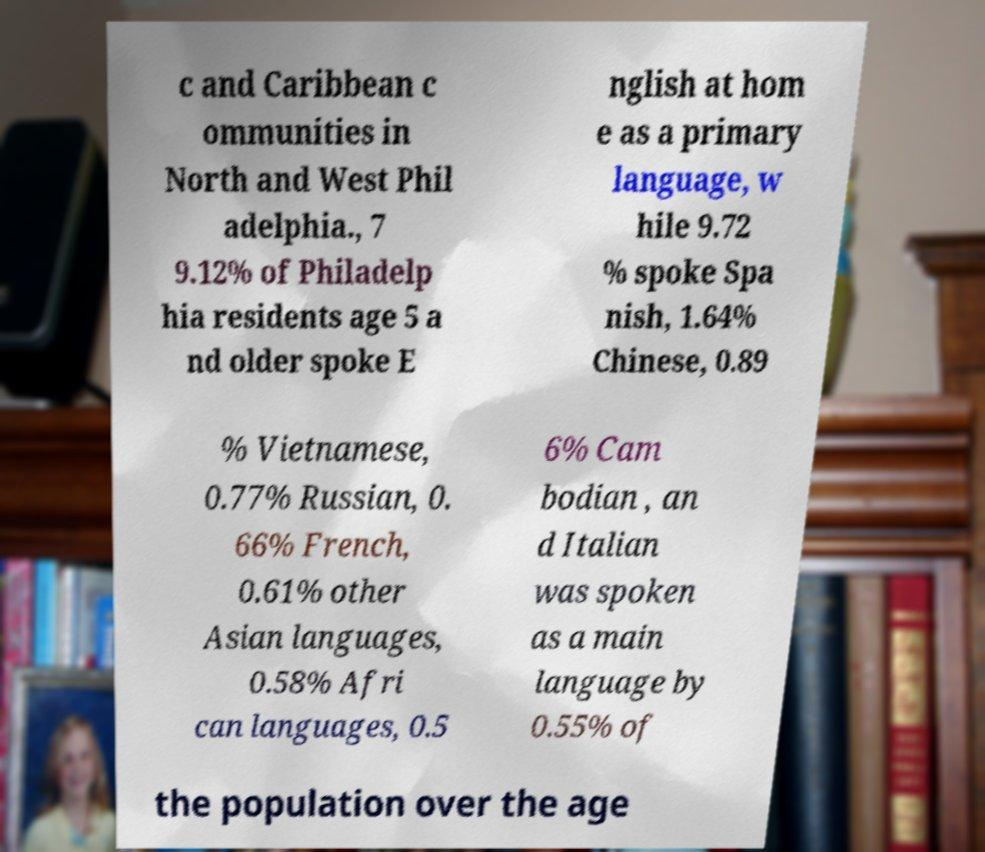I need the written content from this picture converted into text. Can you do that? c and Caribbean c ommunities in North and West Phil adelphia., 7 9.12% of Philadelp hia residents age 5 a nd older spoke E nglish at hom e as a primary language, w hile 9.72 % spoke Spa nish, 1.64% Chinese, 0.89 % Vietnamese, 0.77% Russian, 0. 66% French, 0.61% other Asian languages, 0.58% Afri can languages, 0.5 6% Cam bodian , an d Italian was spoken as a main language by 0.55% of the population over the age 